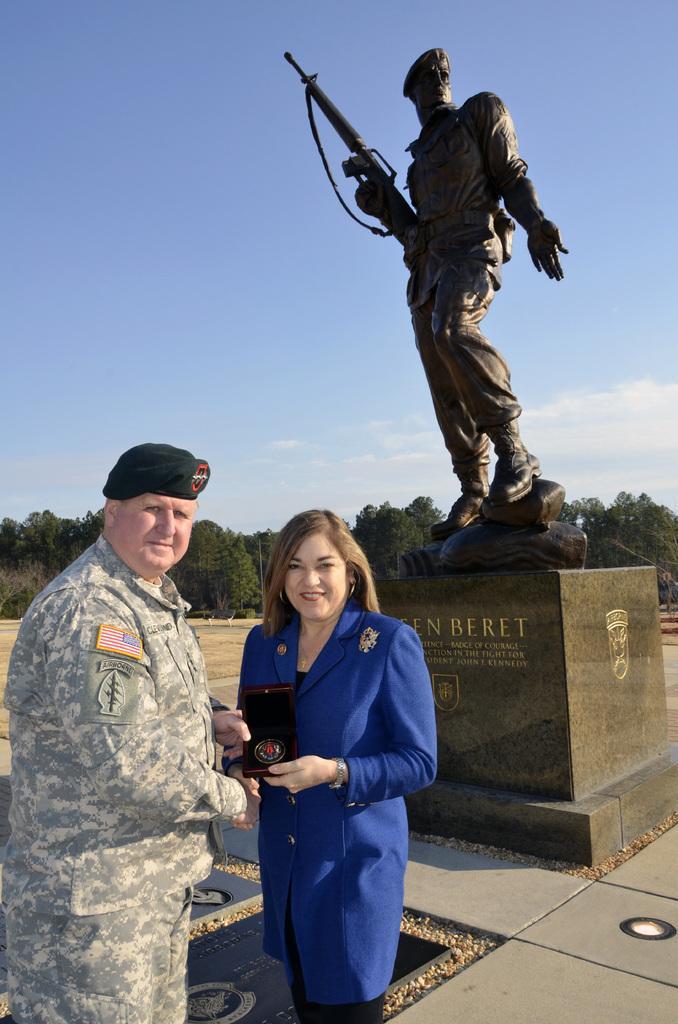Please provide a concise description of this image. In this picture we can observe a statue of a person holding a gun. We can observe two persons in front of the statue. One of them is a man and other is a woman. In the background we can observe some trees and a sky with some clouds. 